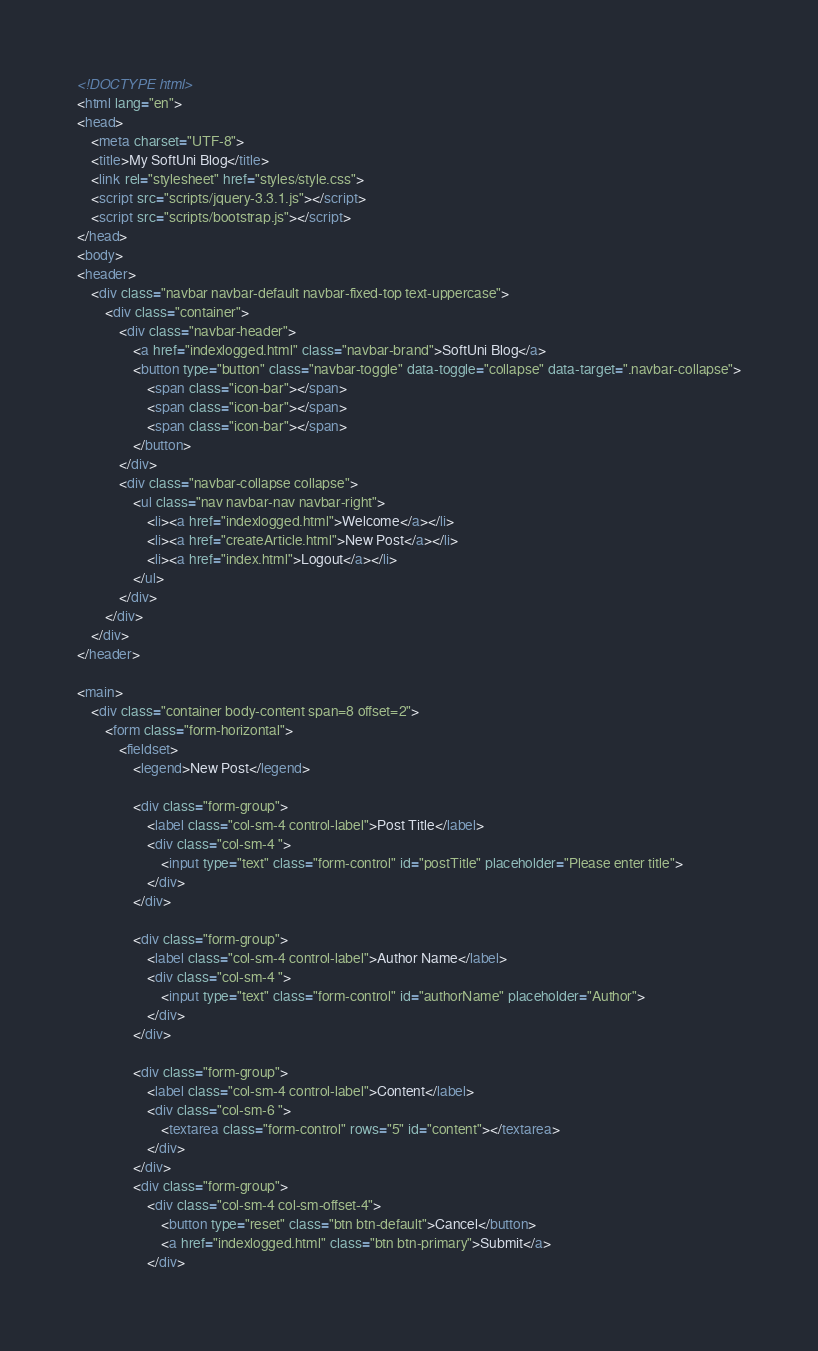<code> <loc_0><loc_0><loc_500><loc_500><_HTML_><!DOCTYPE html>
<html lang="en">
<head>
    <meta charset="UTF-8">
    <title>My SoftUni Blog</title>
    <link rel="stylesheet" href="styles/style.css">
    <script src="scripts/jquery-3.3.1.js"></script>
    <script src="scripts/bootstrap.js"></script>
</head>
<body>
<header>
    <div class="navbar navbar-default navbar-fixed-top text-uppercase">
        <div class="container">
            <div class="navbar-header">
                <a href="indexlogged.html" class="navbar-brand">SoftUni Blog</a>
                <button type="button" class="navbar-toggle" data-toggle="collapse" data-target=".navbar-collapse">
                    <span class="icon-bar"></span>
                    <span class="icon-bar"></span>
                    <span class="icon-bar"></span>
                </button>
            </div>
            <div class="navbar-collapse collapse">
                <ul class="nav navbar-nav navbar-right">
                    <li><a href="indexlogged.html">Welcome</a></li>
                    <li><a href="createArticle.html">New Post</a></li>
                    <li><a href="index.html">Logout</a></li>
                </ul>
            </div>
        </div>
    </div>
</header>

<main>
    <div class="container body-content span=8 offset=2">
        <form class="form-horizontal">
            <fieldset>
                <legend>New Post</legend>

                <div class="form-group">
                    <label class="col-sm-4 control-label">Post Title</label>
                    <div class="col-sm-4 ">
                        <input type="text" class="form-control" id="postTitle" placeholder="Please enter title">
                    </div>
                </div>

                <div class="form-group">
                    <label class="col-sm-4 control-label">Author Name</label>
                    <div class="col-sm-4 ">
                        <input type="text" class="form-control" id="authorName" placeholder="Author">
                    </div>
                </div>

                <div class="form-group">
                    <label class="col-sm-4 control-label">Content</label>
                    <div class="col-sm-6 ">
                        <textarea class="form-control" rows="5" id="content"></textarea>
                    </div>
                </div>
                <div class="form-group">
                    <div class="col-sm-4 col-sm-offset-4">
                        <button type="reset" class="btn btn-default">Cancel</button>
                        <a href="indexlogged.html" class="btn btn-primary">Submit</a>
                    </div></code> 